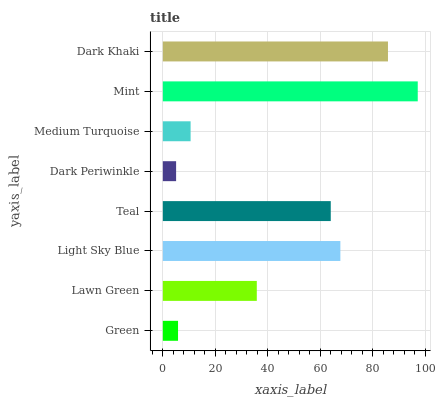Is Dark Periwinkle the minimum?
Answer yes or no. Yes. Is Mint the maximum?
Answer yes or no. Yes. Is Lawn Green the minimum?
Answer yes or no. No. Is Lawn Green the maximum?
Answer yes or no. No. Is Lawn Green greater than Green?
Answer yes or no. Yes. Is Green less than Lawn Green?
Answer yes or no. Yes. Is Green greater than Lawn Green?
Answer yes or no. No. Is Lawn Green less than Green?
Answer yes or no. No. Is Teal the high median?
Answer yes or no. Yes. Is Lawn Green the low median?
Answer yes or no. Yes. Is Dark Khaki the high median?
Answer yes or no. No. Is Green the low median?
Answer yes or no. No. 